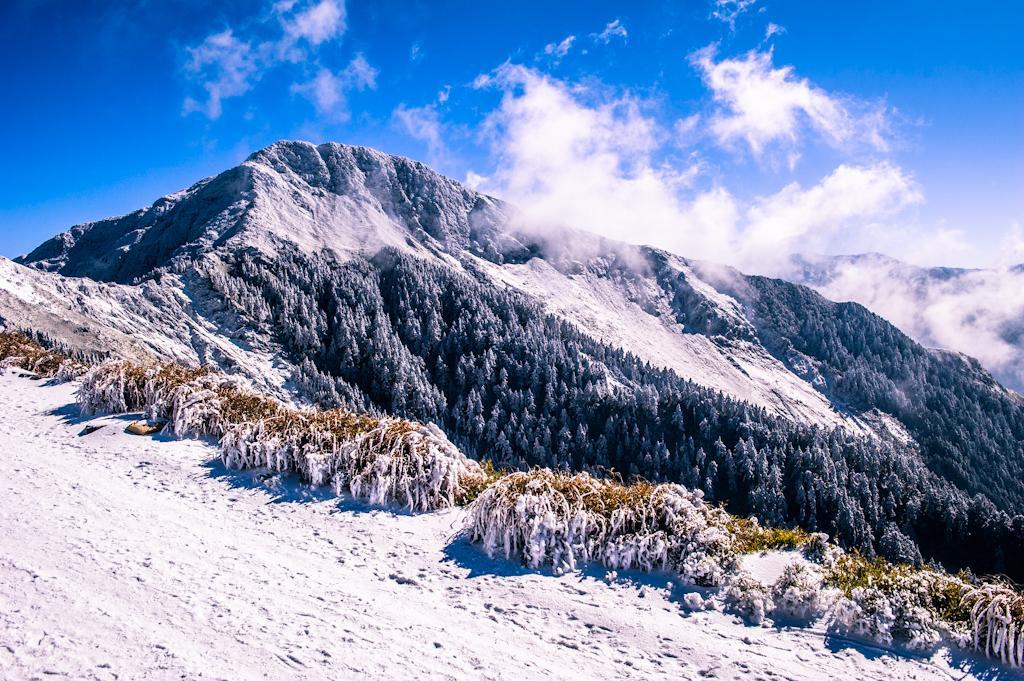In one or two sentences, can you explain what this image depicts? At the bottom of the image I can see the snow and there are some plants covered with snow. In the background, I can see a mountain and many trees. At the top of the image I can see the sky and clouds. 